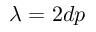Convert formula to latex. <formula><loc_0><loc_0><loc_500><loc_500>\lambda = 2 d p</formula> 